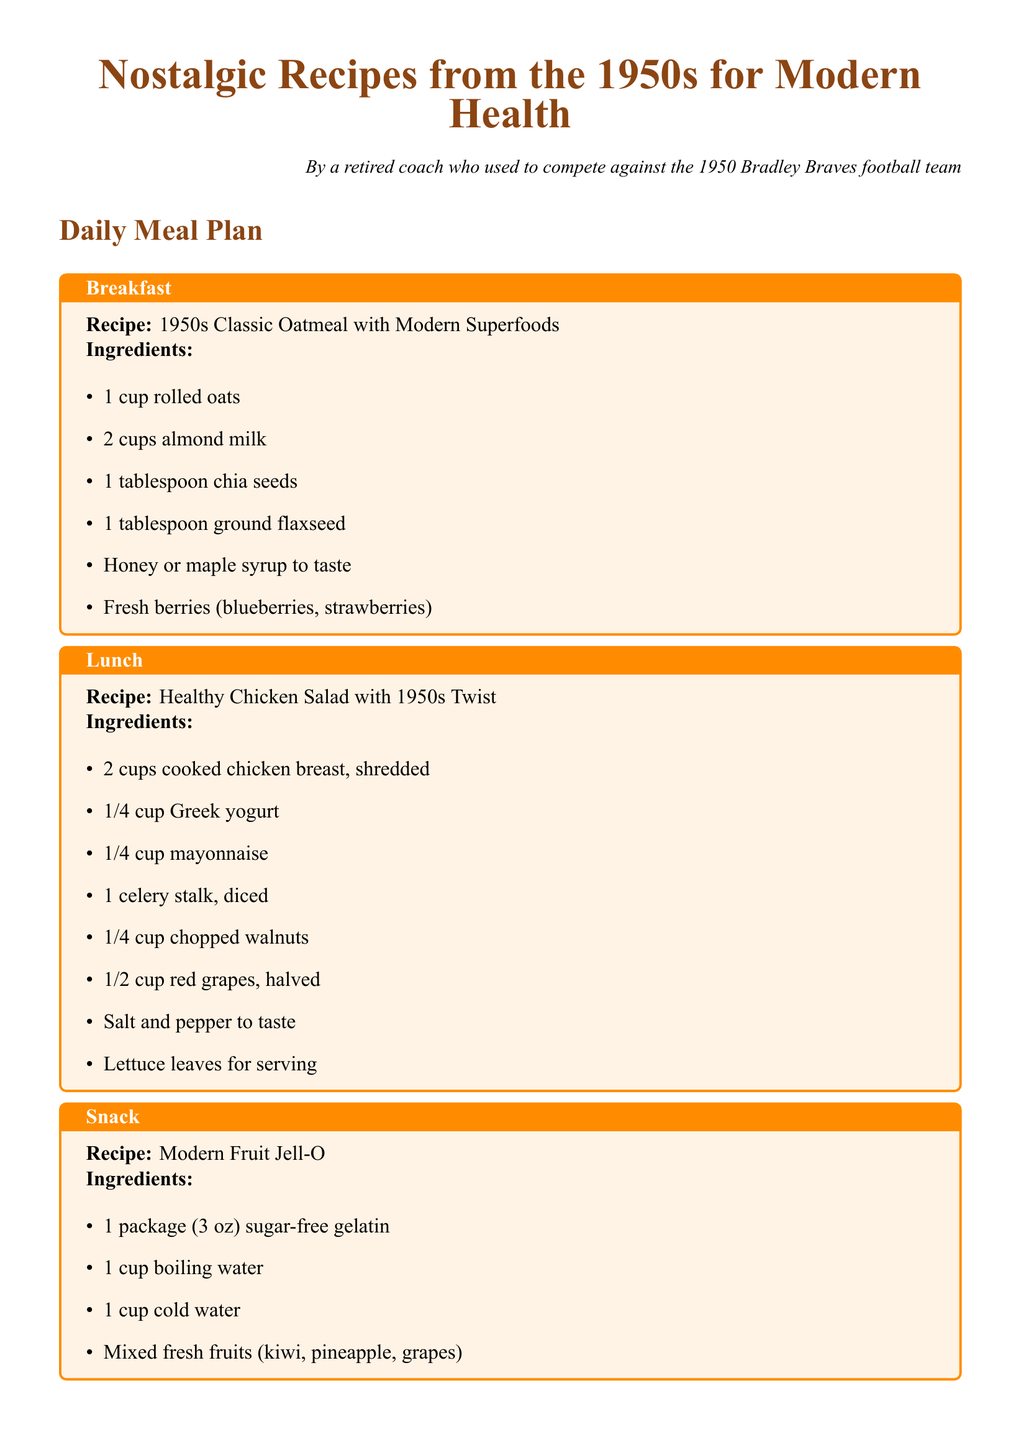What is the title of the document? The title of the document is prominently displayed at the top, introducing the focus on nostalgic recipes from the 1950s.
Answer: Nostalgic Recipes from the 1950s for Modern Health Who authored the document? The author is identified in a small italicized line below the title, indicating their background.
Answer: a retired coach who used to compete against the 1950 Bradley Braves football team How many meals are included in the daily meal plan? The document features five distinct meal boxes, indicating a full daily meal plan.
Answer: Five What type of milk is used in the breakfast recipe? The ingredients list specifies using almond milk in the oatmeal preparation.
Answer: Almond milk What ingredient is used for sweetness in the dessert? The recipe for the classic apple pie includes honey as a sweetening agent.
Answer: Honey What is the main protein source in the dinner recipe? The dinner recipe explicitly mentions using lean ground turkey as the protein source.
Answer: Lean ground turkey Which ingredient is listed in both the breakfast and dessert recipes? The ingredient list indicates that honey appears in both recipes as a sweetener.
Answer: Honey How many cups of cooked chicken breast are needed for lunch? The lunch recipe requires two cups of shredded cooked chicken breast.
Answer: Two cups What is the primary fruit used in the snack recipe? The snack recipe features mixed fresh fruits, highlighting a variety of options but not a single primary fruit.
Answer: Mixed fresh fruits 